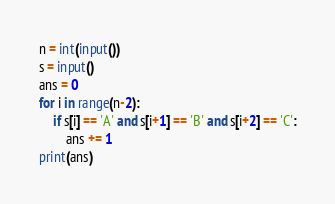<code> <loc_0><loc_0><loc_500><loc_500><_Python_>n = int(input())
s = input()
ans = 0
for i in range(n-2):
    if s[i] == 'A' and s[i+1] == 'B' and s[i+2] == 'C':
        ans += 1
print(ans)</code> 